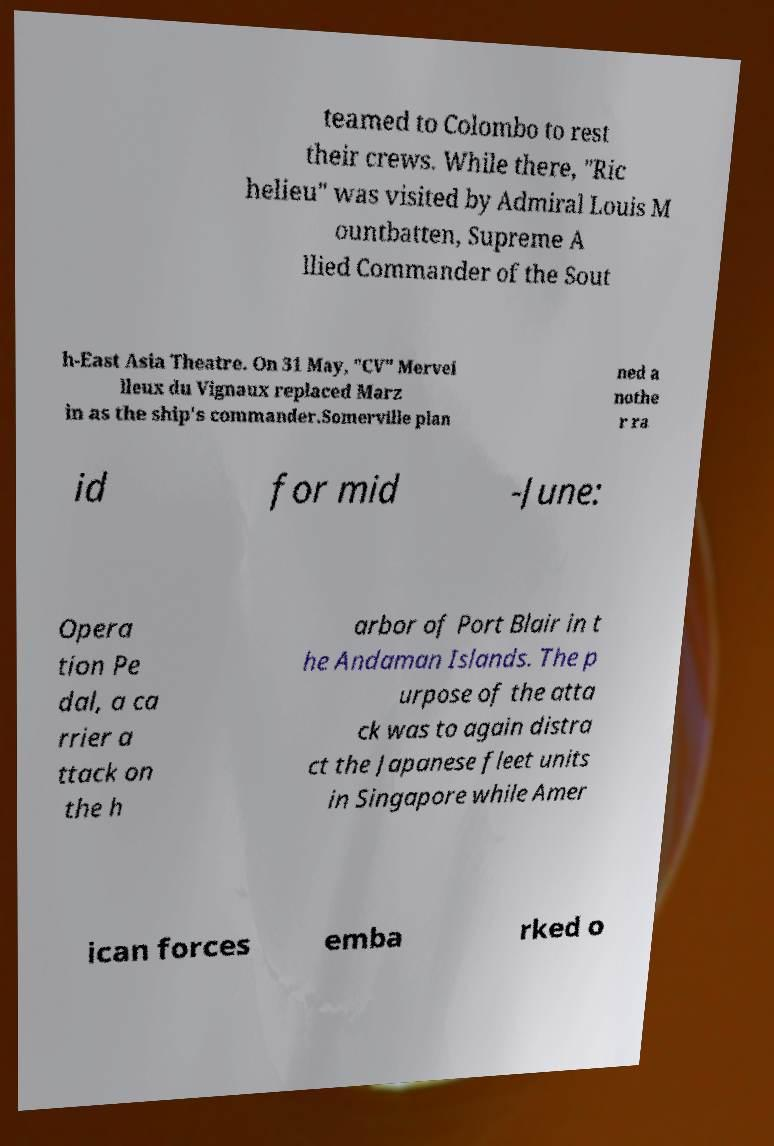Please read and relay the text visible in this image. What does it say? teamed to Colombo to rest their crews. While there, "Ric helieu" was visited by Admiral Louis M ountbatten, Supreme A llied Commander of the Sout h-East Asia Theatre. On 31 May, "CV" Mervei lleux du Vignaux replaced Marz in as the ship's commander.Somerville plan ned a nothe r ra id for mid -June: Opera tion Pe dal, a ca rrier a ttack on the h arbor of Port Blair in t he Andaman Islands. The p urpose of the atta ck was to again distra ct the Japanese fleet units in Singapore while Amer ican forces emba rked o 